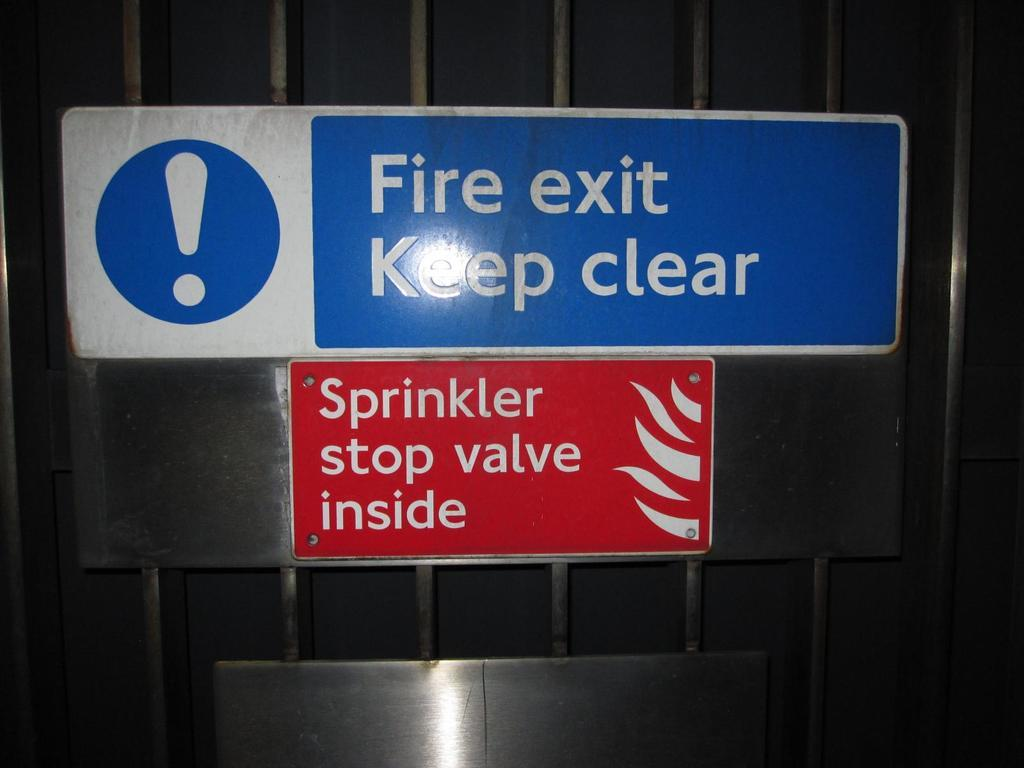<image>
Describe the image concisely. A blue and white fire exit is posted above a red sign. 